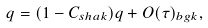<formula> <loc_0><loc_0><loc_500><loc_500>q = ( 1 - C _ { s h a k } ) q + O ( \tau ) _ { b g k } ,</formula> 